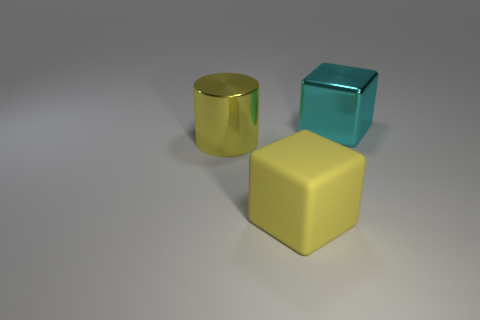Add 3 small gray metal cubes. How many objects exist? 6 Subtract all cylinders. How many objects are left? 2 Subtract 0 yellow spheres. How many objects are left? 3 Subtract all shiny cylinders. Subtract all cylinders. How many objects are left? 1 Add 1 blocks. How many blocks are left? 3 Add 3 big purple rubber balls. How many big purple rubber balls exist? 3 